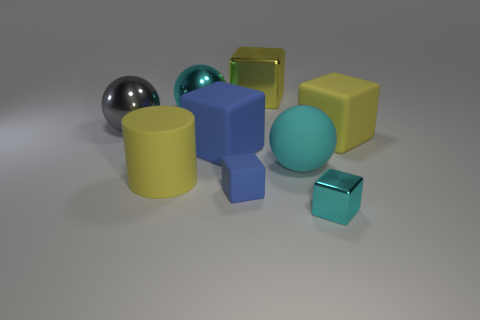Is there a large cyan thing that has the same shape as the gray shiny thing?
Provide a short and direct response. Yes. There is a cyan object that is in front of the yellow matte object that is left of the large cyan rubber sphere; what number of tiny cyan blocks are left of it?
Offer a terse response. 0. There is a matte cylinder; is it the same color as the rubber object right of the cyan block?
Offer a terse response. Yes. What number of things are matte blocks in front of the rubber sphere or metallic things that are behind the small metallic block?
Your response must be concise. 4. Is the number of metal cubes that are on the right side of the small metal block greater than the number of blue blocks that are in front of the large rubber ball?
Your answer should be compact. No. What material is the yellow block to the right of the large ball in front of the big yellow block that is in front of the yellow metallic block made of?
Your response must be concise. Rubber. Is the shape of the big object that is on the left side of the large yellow cylinder the same as the metallic thing in front of the gray object?
Keep it short and to the point. No. Are there any red metallic objects that have the same size as the yellow matte cube?
Offer a terse response. No. How many gray objects are either big matte things or matte things?
Offer a terse response. 0. What number of things are the same color as the rubber cylinder?
Keep it short and to the point. 2. 